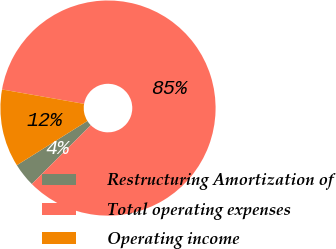Convert chart to OTSL. <chart><loc_0><loc_0><loc_500><loc_500><pie_chart><fcel>Restructuring Amortization of<fcel>Total operating expenses<fcel>Operating income<nl><fcel>3.57%<fcel>84.75%<fcel>11.68%<nl></chart> 